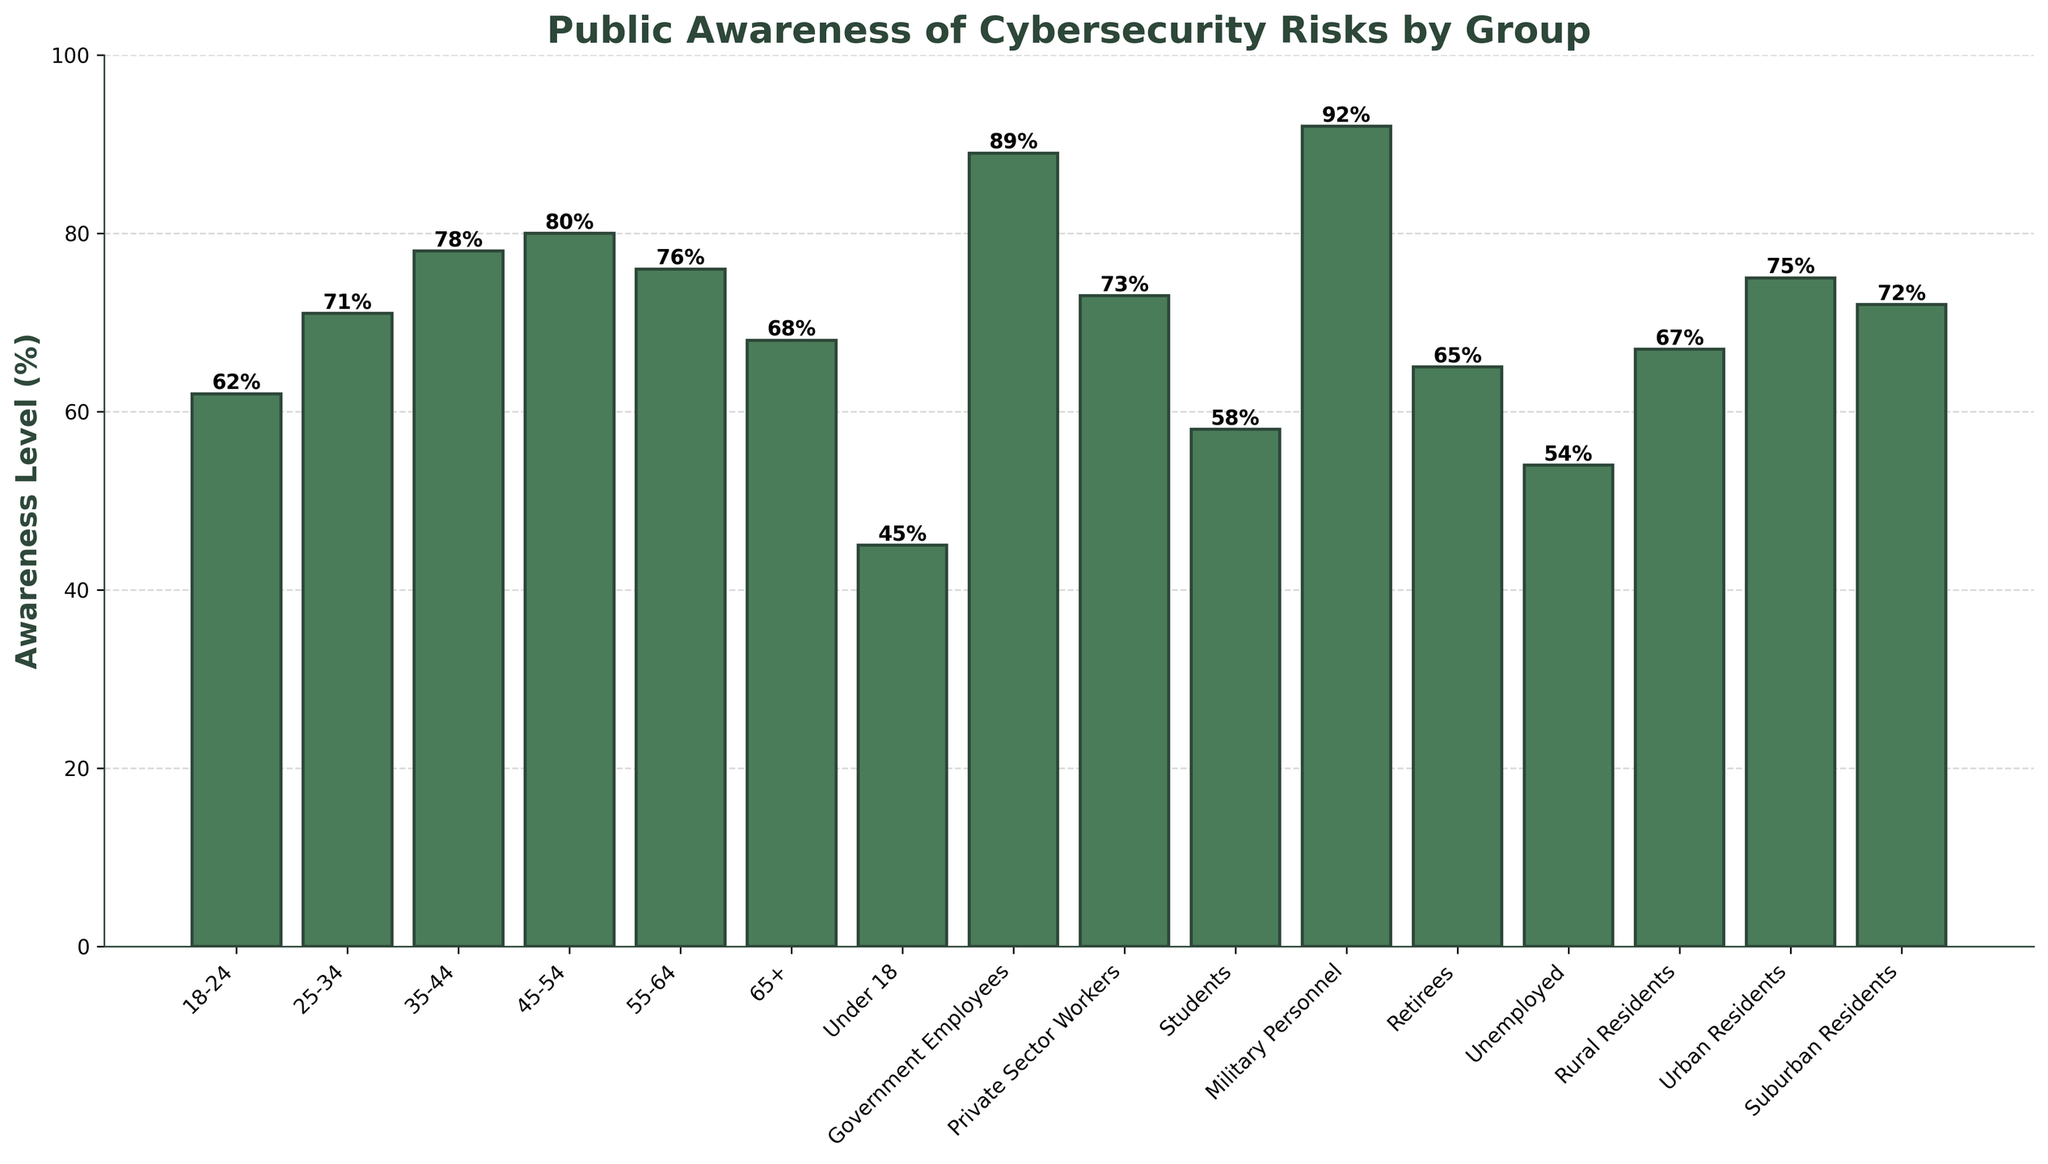What is the awareness level of 18-24-year-olds compared to retirees? Look at the bar heights corresponding to the 18-24 age group and retirees. The awareness level for 18-24-year-olds is 62% and for retirees is 65%.
Answer: 62% vs 65% Which group has the highest level of cybersecurity awareness? Find the tallest bar on the chart. The Military Personnel group has the highest awareness level at 92%.
Answer: Military Personnel How much higher is the awareness level of government employees compared to students? Identify the bar heights for government employees and students. Government employees' awareness is 89%, and students' is 58%. Subtract the latter from the former: 89% - 58% = 31%.
Answer: 31% What is the average awareness level among those under 18, students, and unemployed? Sum the awareness levels of the three groups (45%, 58%, 54%). The sum is 45 + 58 + 54 = 157. Divide by the number of groups, which is 3: 157 / 3 = 52.33%.
Answer: 52.33% Which has a higher awareness level: urban residents or rural residents? Compare the bar heights of urban residents and rural residents. Urban residents have an awareness level of 75% and rural residents have 67%.
Answer: Urban residents What is the total awareness level percentage if you sum up the values for the age groups 25-34, 35-44, and 45-54? Sum the awareness levels for ages 25-34 (71%), 35-44 (78%), and 45-54 (80%). The sum is 71 + 78 + 80 = 229.
Answer: 229% What is the difference in awareness levels between the highest scoring group and the lowest scoring group? Identify the highest and lowest awareness levels. Military Personnel (92%) is the highest and Under 18 (45%) is the lowest. Subtract the lowest from the highest: 92% - 45% = 47%.
Answer: 47% Which group has a visually similar height to suburban residents' awareness level? Find bars close in height to suburban residents. Suburban residents have an awareness level of 72%. The bar for Private Sector Workers, with 73%, appears similar in height.
Answer: Private Sector Workers 